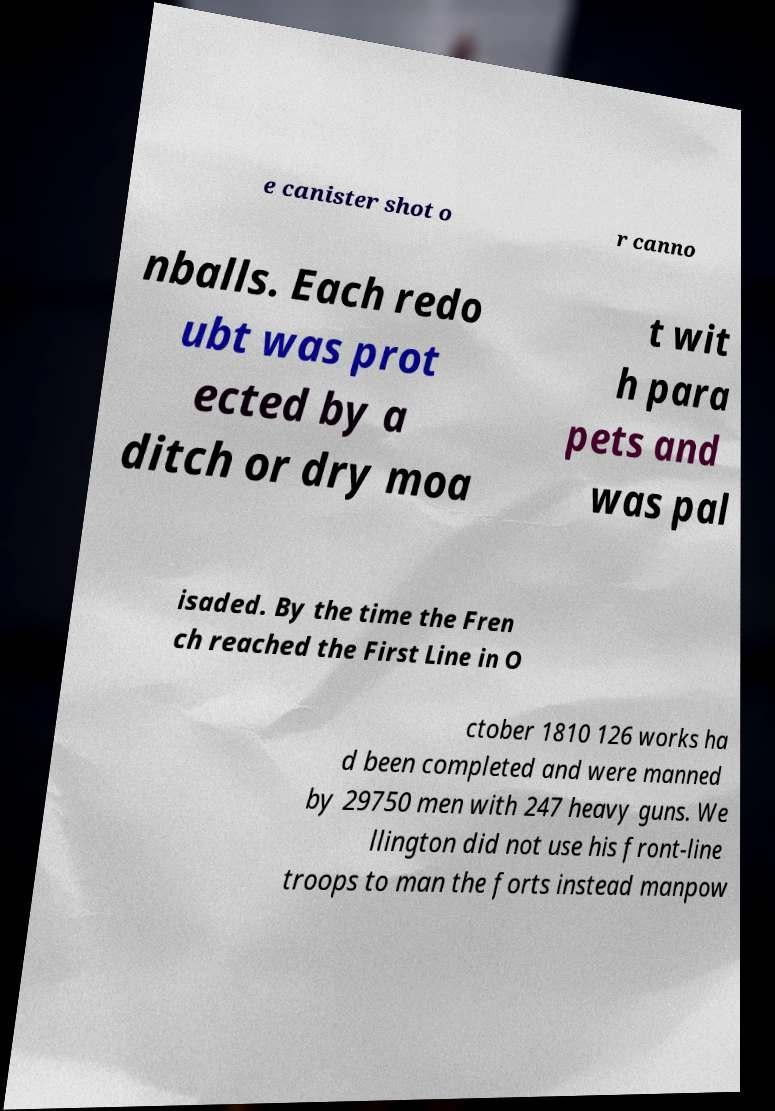Can you accurately transcribe the text from the provided image for me? e canister shot o r canno nballs. Each redo ubt was prot ected by a ditch or dry moa t wit h para pets and was pal isaded. By the time the Fren ch reached the First Line in O ctober 1810 126 works ha d been completed and were manned by 29750 men with 247 heavy guns. We llington did not use his front-line troops to man the forts instead manpow 